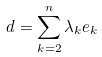Convert formula to latex. <formula><loc_0><loc_0><loc_500><loc_500>d = \sum _ { k = 2 } ^ { n } \lambda _ { k } e _ { k } \\</formula> 